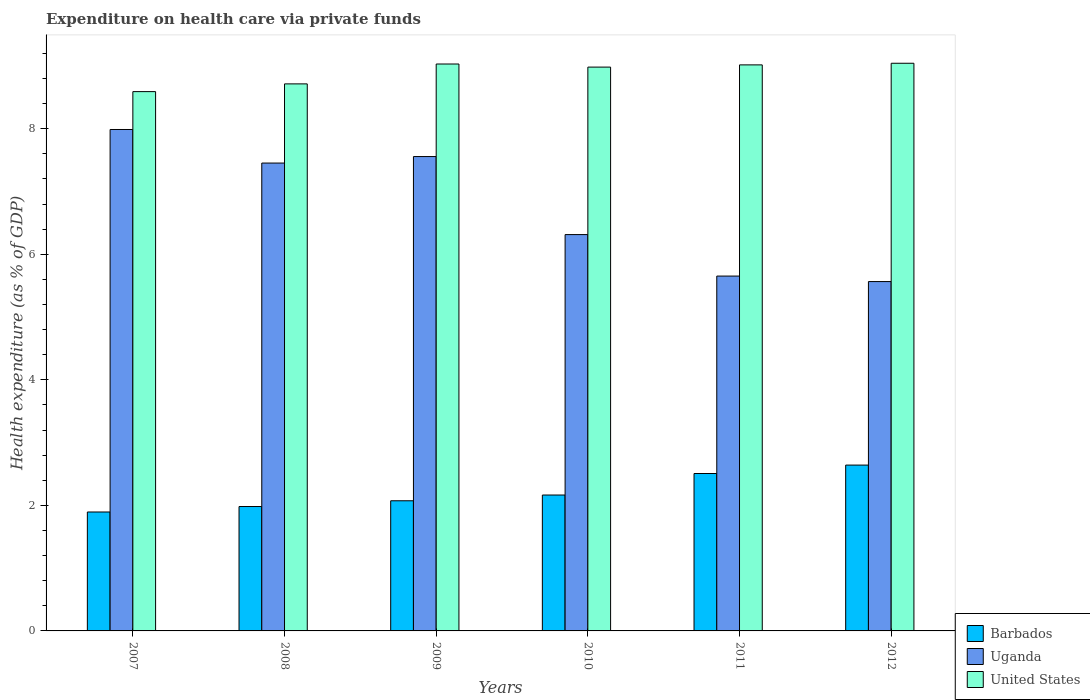How many groups of bars are there?
Ensure brevity in your answer.  6. Are the number of bars per tick equal to the number of legend labels?
Keep it short and to the point. Yes. Are the number of bars on each tick of the X-axis equal?
Provide a short and direct response. Yes. How many bars are there on the 4th tick from the left?
Offer a terse response. 3. How many bars are there on the 1st tick from the right?
Provide a short and direct response. 3. What is the label of the 1st group of bars from the left?
Your response must be concise. 2007. In how many cases, is the number of bars for a given year not equal to the number of legend labels?
Your answer should be very brief. 0. What is the expenditure made on health care in United States in 2007?
Offer a terse response. 8.59. Across all years, what is the maximum expenditure made on health care in United States?
Your answer should be compact. 9.04. Across all years, what is the minimum expenditure made on health care in Uganda?
Keep it short and to the point. 5.57. In which year was the expenditure made on health care in Uganda minimum?
Your answer should be very brief. 2012. What is the total expenditure made on health care in Uganda in the graph?
Offer a terse response. 40.53. What is the difference between the expenditure made on health care in Uganda in 2007 and that in 2009?
Offer a very short reply. 0.43. What is the difference between the expenditure made on health care in Uganda in 2010 and the expenditure made on health care in United States in 2012?
Provide a short and direct response. -2.73. What is the average expenditure made on health care in United States per year?
Provide a short and direct response. 8.9. In the year 2011, what is the difference between the expenditure made on health care in United States and expenditure made on health care in Barbados?
Offer a very short reply. 6.51. What is the ratio of the expenditure made on health care in United States in 2008 to that in 2012?
Offer a terse response. 0.96. Is the expenditure made on health care in Uganda in 2010 less than that in 2012?
Offer a terse response. No. Is the difference between the expenditure made on health care in United States in 2008 and 2011 greater than the difference between the expenditure made on health care in Barbados in 2008 and 2011?
Make the answer very short. Yes. What is the difference between the highest and the second highest expenditure made on health care in Uganda?
Offer a terse response. 0.43. What is the difference between the highest and the lowest expenditure made on health care in United States?
Your answer should be very brief. 0.45. In how many years, is the expenditure made on health care in United States greater than the average expenditure made on health care in United States taken over all years?
Provide a succinct answer. 4. What does the 1st bar from the left in 2012 represents?
Your answer should be compact. Barbados. What does the 3rd bar from the right in 2012 represents?
Your answer should be very brief. Barbados. How many bars are there?
Make the answer very short. 18. Are all the bars in the graph horizontal?
Provide a short and direct response. No. Are the values on the major ticks of Y-axis written in scientific E-notation?
Keep it short and to the point. No. Does the graph contain any zero values?
Offer a very short reply. No. Does the graph contain grids?
Keep it short and to the point. No. Where does the legend appear in the graph?
Give a very brief answer. Bottom right. What is the title of the graph?
Offer a very short reply. Expenditure on health care via private funds. What is the label or title of the X-axis?
Offer a very short reply. Years. What is the label or title of the Y-axis?
Offer a terse response. Health expenditure (as % of GDP). What is the Health expenditure (as % of GDP) in Barbados in 2007?
Ensure brevity in your answer.  1.89. What is the Health expenditure (as % of GDP) of Uganda in 2007?
Offer a terse response. 7.99. What is the Health expenditure (as % of GDP) of United States in 2007?
Provide a succinct answer. 8.59. What is the Health expenditure (as % of GDP) in Barbados in 2008?
Make the answer very short. 1.98. What is the Health expenditure (as % of GDP) in Uganda in 2008?
Make the answer very short. 7.45. What is the Health expenditure (as % of GDP) of United States in 2008?
Give a very brief answer. 8.71. What is the Health expenditure (as % of GDP) of Barbados in 2009?
Keep it short and to the point. 2.07. What is the Health expenditure (as % of GDP) of Uganda in 2009?
Your answer should be very brief. 7.56. What is the Health expenditure (as % of GDP) in United States in 2009?
Ensure brevity in your answer.  9.03. What is the Health expenditure (as % of GDP) in Barbados in 2010?
Ensure brevity in your answer.  2.16. What is the Health expenditure (as % of GDP) of Uganda in 2010?
Your answer should be compact. 6.31. What is the Health expenditure (as % of GDP) of United States in 2010?
Keep it short and to the point. 8.98. What is the Health expenditure (as % of GDP) of Barbados in 2011?
Offer a terse response. 2.51. What is the Health expenditure (as % of GDP) in Uganda in 2011?
Offer a terse response. 5.65. What is the Health expenditure (as % of GDP) in United States in 2011?
Make the answer very short. 9.02. What is the Health expenditure (as % of GDP) in Barbados in 2012?
Keep it short and to the point. 2.64. What is the Health expenditure (as % of GDP) in Uganda in 2012?
Your response must be concise. 5.57. What is the Health expenditure (as % of GDP) of United States in 2012?
Give a very brief answer. 9.04. Across all years, what is the maximum Health expenditure (as % of GDP) of Barbados?
Offer a terse response. 2.64. Across all years, what is the maximum Health expenditure (as % of GDP) of Uganda?
Offer a terse response. 7.99. Across all years, what is the maximum Health expenditure (as % of GDP) of United States?
Give a very brief answer. 9.04. Across all years, what is the minimum Health expenditure (as % of GDP) of Barbados?
Your response must be concise. 1.89. Across all years, what is the minimum Health expenditure (as % of GDP) in Uganda?
Give a very brief answer. 5.57. Across all years, what is the minimum Health expenditure (as % of GDP) of United States?
Provide a succinct answer. 8.59. What is the total Health expenditure (as % of GDP) in Barbados in the graph?
Keep it short and to the point. 13.26. What is the total Health expenditure (as % of GDP) of Uganda in the graph?
Provide a short and direct response. 40.53. What is the total Health expenditure (as % of GDP) of United States in the graph?
Your answer should be very brief. 53.38. What is the difference between the Health expenditure (as % of GDP) of Barbados in 2007 and that in 2008?
Your response must be concise. -0.09. What is the difference between the Health expenditure (as % of GDP) of Uganda in 2007 and that in 2008?
Give a very brief answer. 0.53. What is the difference between the Health expenditure (as % of GDP) of United States in 2007 and that in 2008?
Make the answer very short. -0.12. What is the difference between the Health expenditure (as % of GDP) in Barbados in 2007 and that in 2009?
Your answer should be compact. -0.18. What is the difference between the Health expenditure (as % of GDP) of Uganda in 2007 and that in 2009?
Your answer should be compact. 0.43. What is the difference between the Health expenditure (as % of GDP) in United States in 2007 and that in 2009?
Provide a short and direct response. -0.44. What is the difference between the Health expenditure (as % of GDP) of Barbados in 2007 and that in 2010?
Ensure brevity in your answer.  -0.27. What is the difference between the Health expenditure (as % of GDP) in Uganda in 2007 and that in 2010?
Your answer should be very brief. 1.67. What is the difference between the Health expenditure (as % of GDP) of United States in 2007 and that in 2010?
Your answer should be compact. -0.39. What is the difference between the Health expenditure (as % of GDP) of Barbados in 2007 and that in 2011?
Your answer should be compact. -0.61. What is the difference between the Health expenditure (as % of GDP) in Uganda in 2007 and that in 2011?
Your answer should be very brief. 2.33. What is the difference between the Health expenditure (as % of GDP) of United States in 2007 and that in 2011?
Your answer should be very brief. -0.43. What is the difference between the Health expenditure (as % of GDP) in Barbados in 2007 and that in 2012?
Provide a succinct answer. -0.75. What is the difference between the Health expenditure (as % of GDP) in Uganda in 2007 and that in 2012?
Your answer should be very brief. 2.42. What is the difference between the Health expenditure (as % of GDP) in United States in 2007 and that in 2012?
Provide a succinct answer. -0.45. What is the difference between the Health expenditure (as % of GDP) in Barbados in 2008 and that in 2009?
Offer a terse response. -0.09. What is the difference between the Health expenditure (as % of GDP) of Uganda in 2008 and that in 2009?
Your answer should be very brief. -0.1. What is the difference between the Health expenditure (as % of GDP) in United States in 2008 and that in 2009?
Your response must be concise. -0.32. What is the difference between the Health expenditure (as % of GDP) of Barbados in 2008 and that in 2010?
Offer a terse response. -0.18. What is the difference between the Health expenditure (as % of GDP) in Uganda in 2008 and that in 2010?
Make the answer very short. 1.14. What is the difference between the Health expenditure (as % of GDP) of United States in 2008 and that in 2010?
Offer a very short reply. -0.27. What is the difference between the Health expenditure (as % of GDP) in Barbados in 2008 and that in 2011?
Give a very brief answer. -0.53. What is the difference between the Health expenditure (as % of GDP) of Uganda in 2008 and that in 2011?
Make the answer very short. 1.8. What is the difference between the Health expenditure (as % of GDP) in United States in 2008 and that in 2011?
Your answer should be compact. -0.3. What is the difference between the Health expenditure (as % of GDP) in Barbados in 2008 and that in 2012?
Offer a terse response. -0.66. What is the difference between the Health expenditure (as % of GDP) of Uganda in 2008 and that in 2012?
Your answer should be compact. 1.89. What is the difference between the Health expenditure (as % of GDP) of United States in 2008 and that in 2012?
Give a very brief answer. -0.33. What is the difference between the Health expenditure (as % of GDP) in Barbados in 2009 and that in 2010?
Offer a very short reply. -0.09. What is the difference between the Health expenditure (as % of GDP) in Uganda in 2009 and that in 2010?
Your answer should be compact. 1.24. What is the difference between the Health expenditure (as % of GDP) of United States in 2009 and that in 2010?
Make the answer very short. 0.05. What is the difference between the Health expenditure (as % of GDP) in Barbados in 2009 and that in 2011?
Ensure brevity in your answer.  -0.43. What is the difference between the Health expenditure (as % of GDP) of Uganda in 2009 and that in 2011?
Give a very brief answer. 1.9. What is the difference between the Health expenditure (as % of GDP) in United States in 2009 and that in 2011?
Provide a short and direct response. 0.01. What is the difference between the Health expenditure (as % of GDP) of Barbados in 2009 and that in 2012?
Ensure brevity in your answer.  -0.57. What is the difference between the Health expenditure (as % of GDP) in Uganda in 2009 and that in 2012?
Keep it short and to the point. 1.99. What is the difference between the Health expenditure (as % of GDP) of United States in 2009 and that in 2012?
Give a very brief answer. -0.01. What is the difference between the Health expenditure (as % of GDP) of Barbados in 2010 and that in 2011?
Provide a short and direct response. -0.34. What is the difference between the Health expenditure (as % of GDP) of Uganda in 2010 and that in 2011?
Make the answer very short. 0.66. What is the difference between the Health expenditure (as % of GDP) in United States in 2010 and that in 2011?
Provide a succinct answer. -0.04. What is the difference between the Health expenditure (as % of GDP) of Barbados in 2010 and that in 2012?
Keep it short and to the point. -0.48. What is the difference between the Health expenditure (as % of GDP) of Uganda in 2010 and that in 2012?
Keep it short and to the point. 0.75. What is the difference between the Health expenditure (as % of GDP) of United States in 2010 and that in 2012?
Offer a very short reply. -0.06. What is the difference between the Health expenditure (as % of GDP) of Barbados in 2011 and that in 2012?
Your answer should be very brief. -0.13. What is the difference between the Health expenditure (as % of GDP) in Uganda in 2011 and that in 2012?
Give a very brief answer. 0.09. What is the difference between the Health expenditure (as % of GDP) of United States in 2011 and that in 2012?
Keep it short and to the point. -0.03. What is the difference between the Health expenditure (as % of GDP) of Barbados in 2007 and the Health expenditure (as % of GDP) of Uganda in 2008?
Offer a terse response. -5.56. What is the difference between the Health expenditure (as % of GDP) in Barbados in 2007 and the Health expenditure (as % of GDP) in United States in 2008?
Offer a terse response. -6.82. What is the difference between the Health expenditure (as % of GDP) in Uganda in 2007 and the Health expenditure (as % of GDP) in United States in 2008?
Offer a very short reply. -0.73. What is the difference between the Health expenditure (as % of GDP) in Barbados in 2007 and the Health expenditure (as % of GDP) in Uganda in 2009?
Make the answer very short. -5.66. What is the difference between the Health expenditure (as % of GDP) in Barbados in 2007 and the Health expenditure (as % of GDP) in United States in 2009?
Make the answer very short. -7.14. What is the difference between the Health expenditure (as % of GDP) in Uganda in 2007 and the Health expenditure (as % of GDP) in United States in 2009?
Provide a succinct answer. -1.04. What is the difference between the Health expenditure (as % of GDP) in Barbados in 2007 and the Health expenditure (as % of GDP) in Uganda in 2010?
Ensure brevity in your answer.  -4.42. What is the difference between the Health expenditure (as % of GDP) of Barbados in 2007 and the Health expenditure (as % of GDP) of United States in 2010?
Your answer should be very brief. -7.09. What is the difference between the Health expenditure (as % of GDP) of Uganda in 2007 and the Health expenditure (as % of GDP) of United States in 2010?
Provide a succinct answer. -0.99. What is the difference between the Health expenditure (as % of GDP) in Barbados in 2007 and the Health expenditure (as % of GDP) in Uganda in 2011?
Ensure brevity in your answer.  -3.76. What is the difference between the Health expenditure (as % of GDP) of Barbados in 2007 and the Health expenditure (as % of GDP) of United States in 2011?
Offer a very short reply. -7.12. What is the difference between the Health expenditure (as % of GDP) in Uganda in 2007 and the Health expenditure (as % of GDP) in United States in 2011?
Offer a terse response. -1.03. What is the difference between the Health expenditure (as % of GDP) of Barbados in 2007 and the Health expenditure (as % of GDP) of Uganda in 2012?
Offer a very short reply. -3.67. What is the difference between the Health expenditure (as % of GDP) in Barbados in 2007 and the Health expenditure (as % of GDP) in United States in 2012?
Offer a very short reply. -7.15. What is the difference between the Health expenditure (as % of GDP) in Uganda in 2007 and the Health expenditure (as % of GDP) in United States in 2012?
Provide a short and direct response. -1.05. What is the difference between the Health expenditure (as % of GDP) in Barbados in 2008 and the Health expenditure (as % of GDP) in Uganda in 2009?
Provide a short and direct response. -5.57. What is the difference between the Health expenditure (as % of GDP) of Barbados in 2008 and the Health expenditure (as % of GDP) of United States in 2009?
Make the answer very short. -7.05. What is the difference between the Health expenditure (as % of GDP) in Uganda in 2008 and the Health expenditure (as % of GDP) in United States in 2009?
Provide a succinct answer. -1.58. What is the difference between the Health expenditure (as % of GDP) of Barbados in 2008 and the Health expenditure (as % of GDP) of Uganda in 2010?
Your answer should be compact. -4.33. What is the difference between the Health expenditure (as % of GDP) of Barbados in 2008 and the Health expenditure (as % of GDP) of United States in 2010?
Provide a short and direct response. -7. What is the difference between the Health expenditure (as % of GDP) of Uganda in 2008 and the Health expenditure (as % of GDP) of United States in 2010?
Provide a succinct answer. -1.53. What is the difference between the Health expenditure (as % of GDP) in Barbados in 2008 and the Health expenditure (as % of GDP) in Uganda in 2011?
Your answer should be compact. -3.67. What is the difference between the Health expenditure (as % of GDP) in Barbados in 2008 and the Health expenditure (as % of GDP) in United States in 2011?
Offer a terse response. -7.04. What is the difference between the Health expenditure (as % of GDP) in Uganda in 2008 and the Health expenditure (as % of GDP) in United States in 2011?
Your answer should be compact. -1.56. What is the difference between the Health expenditure (as % of GDP) of Barbados in 2008 and the Health expenditure (as % of GDP) of Uganda in 2012?
Provide a succinct answer. -3.58. What is the difference between the Health expenditure (as % of GDP) in Barbados in 2008 and the Health expenditure (as % of GDP) in United States in 2012?
Your answer should be very brief. -7.06. What is the difference between the Health expenditure (as % of GDP) in Uganda in 2008 and the Health expenditure (as % of GDP) in United States in 2012?
Keep it short and to the point. -1.59. What is the difference between the Health expenditure (as % of GDP) in Barbados in 2009 and the Health expenditure (as % of GDP) in Uganda in 2010?
Your response must be concise. -4.24. What is the difference between the Health expenditure (as % of GDP) of Barbados in 2009 and the Health expenditure (as % of GDP) of United States in 2010?
Provide a succinct answer. -6.91. What is the difference between the Health expenditure (as % of GDP) of Uganda in 2009 and the Health expenditure (as % of GDP) of United States in 2010?
Give a very brief answer. -1.43. What is the difference between the Health expenditure (as % of GDP) in Barbados in 2009 and the Health expenditure (as % of GDP) in Uganda in 2011?
Provide a short and direct response. -3.58. What is the difference between the Health expenditure (as % of GDP) of Barbados in 2009 and the Health expenditure (as % of GDP) of United States in 2011?
Offer a terse response. -6.94. What is the difference between the Health expenditure (as % of GDP) in Uganda in 2009 and the Health expenditure (as % of GDP) in United States in 2011?
Your answer should be very brief. -1.46. What is the difference between the Health expenditure (as % of GDP) of Barbados in 2009 and the Health expenditure (as % of GDP) of Uganda in 2012?
Your answer should be compact. -3.49. What is the difference between the Health expenditure (as % of GDP) of Barbados in 2009 and the Health expenditure (as % of GDP) of United States in 2012?
Provide a succinct answer. -6.97. What is the difference between the Health expenditure (as % of GDP) in Uganda in 2009 and the Health expenditure (as % of GDP) in United States in 2012?
Make the answer very short. -1.49. What is the difference between the Health expenditure (as % of GDP) of Barbados in 2010 and the Health expenditure (as % of GDP) of Uganda in 2011?
Your response must be concise. -3.49. What is the difference between the Health expenditure (as % of GDP) in Barbados in 2010 and the Health expenditure (as % of GDP) in United States in 2011?
Offer a terse response. -6.85. What is the difference between the Health expenditure (as % of GDP) in Uganda in 2010 and the Health expenditure (as % of GDP) in United States in 2011?
Offer a terse response. -2.7. What is the difference between the Health expenditure (as % of GDP) in Barbados in 2010 and the Health expenditure (as % of GDP) in Uganda in 2012?
Ensure brevity in your answer.  -3.4. What is the difference between the Health expenditure (as % of GDP) of Barbados in 2010 and the Health expenditure (as % of GDP) of United States in 2012?
Offer a terse response. -6.88. What is the difference between the Health expenditure (as % of GDP) in Uganda in 2010 and the Health expenditure (as % of GDP) in United States in 2012?
Offer a terse response. -2.73. What is the difference between the Health expenditure (as % of GDP) in Barbados in 2011 and the Health expenditure (as % of GDP) in Uganda in 2012?
Give a very brief answer. -3.06. What is the difference between the Health expenditure (as % of GDP) in Barbados in 2011 and the Health expenditure (as % of GDP) in United States in 2012?
Ensure brevity in your answer.  -6.54. What is the difference between the Health expenditure (as % of GDP) of Uganda in 2011 and the Health expenditure (as % of GDP) of United States in 2012?
Your response must be concise. -3.39. What is the average Health expenditure (as % of GDP) of Barbados per year?
Ensure brevity in your answer.  2.21. What is the average Health expenditure (as % of GDP) in Uganda per year?
Give a very brief answer. 6.75. What is the average Health expenditure (as % of GDP) in United States per year?
Ensure brevity in your answer.  8.9. In the year 2007, what is the difference between the Health expenditure (as % of GDP) in Barbados and Health expenditure (as % of GDP) in Uganda?
Your response must be concise. -6.09. In the year 2007, what is the difference between the Health expenditure (as % of GDP) in Barbados and Health expenditure (as % of GDP) in United States?
Your answer should be very brief. -6.7. In the year 2007, what is the difference between the Health expenditure (as % of GDP) in Uganda and Health expenditure (as % of GDP) in United States?
Ensure brevity in your answer.  -0.6. In the year 2008, what is the difference between the Health expenditure (as % of GDP) of Barbados and Health expenditure (as % of GDP) of Uganda?
Make the answer very short. -5.47. In the year 2008, what is the difference between the Health expenditure (as % of GDP) in Barbados and Health expenditure (as % of GDP) in United States?
Ensure brevity in your answer.  -6.73. In the year 2008, what is the difference between the Health expenditure (as % of GDP) in Uganda and Health expenditure (as % of GDP) in United States?
Make the answer very short. -1.26. In the year 2009, what is the difference between the Health expenditure (as % of GDP) of Barbados and Health expenditure (as % of GDP) of Uganda?
Provide a short and direct response. -5.48. In the year 2009, what is the difference between the Health expenditure (as % of GDP) of Barbados and Health expenditure (as % of GDP) of United States?
Give a very brief answer. -6.96. In the year 2009, what is the difference between the Health expenditure (as % of GDP) of Uganda and Health expenditure (as % of GDP) of United States?
Keep it short and to the point. -1.47. In the year 2010, what is the difference between the Health expenditure (as % of GDP) of Barbados and Health expenditure (as % of GDP) of Uganda?
Keep it short and to the point. -4.15. In the year 2010, what is the difference between the Health expenditure (as % of GDP) of Barbados and Health expenditure (as % of GDP) of United States?
Your answer should be very brief. -6.82. In the year 2010, what is the difference between the Health expenditure (as % of GDP) of Uganda and Health expenditure (as % of GDP) of United States?
Provide a succinct answer. -2.67. In the year 2011, what is the difference between the Health expenditure (as % of GDP) of Barbados and Health expenditure (as % of GDP) of Uganda?
Provide a short and direct response. -3.15. In the year 2011, what is the difference between the Health expenditure (as % of GDP) in Barbados and Health expenditure (as % of GDP) in United States?
Make the answer very short. -6.51. In the year 2011, what is the difference between the Health expenditure (as % of GDP) in Uganda and Health expenditure (as % of GDP) in United States?
Offer a terse response. -3.36. In the year 2012, what is the difference between the Health expenditure (as % of GDP) in Barbados and Health expenditure (as % of GDP) in Uganda?
Your answer should be very brief. -2.92. In the year 2012, what is the difference between the Health expenditure (as % of GDP) of Barbados and Health expenditure (as % of GDP) of United States?
Offer a very short reply. -6.4. In the year 2012, what is the difference between the Health expenditure (as % of GDP) in Uganda and Health expenditure (as % of GDP) in United States?
Keep it short and to the point. -3.48. What is the ratio of the Health expenditure (as % of GDP) of Barbados in 2007 to that in 2008?
Make the answer very short. 0.96. What is the ratio of the Health expenditure (as % of GDP) of Uganda in 2007 to that in 2008?
Your response must be concise. 1.07. What is the ratio of the Health expenditure (as % of GDP) in United States in 2007 to that in 2008?
Your answer should be very brief. 0.99. What is the ratio of the Health expenditure (as % of GDP) of Barbados in 2007 to that in 2009?
Offer a very short reply. 0.91. What is the ratio of the Health expenditure (as % of GDP) in Uganda in 2007 to that in 2009?
Your answer should be compact. 1.06. What is the ratio of the Health expenditure (as % of GDP) of United States in 2007 to that in 2009?
Offer a terse response. 0.95. What is the ratio of the Health expenditure (as % of GDP) of Barbados in 2007 to that in 2010?
Your answer should be very brief. 0.88. What is the ratio of the Health expenditure (as % of GDP) in Uganda in 2007 to that in 2010?
Offer a terse response. 1.27. What is the ratio of the Health expenditure (as % of GDP) in United States in 2007 to that in 2010?
Keep it short and to the point. 0.96. What is the ratio of the Health expenditure (as % of GDP) in Barbados in 2007 to that in 2011?
Your answer should be compact. 0.76. What is the ratio of the Health expenditure (as % of GDP) in Uganda in 2007 to that in 2011?
Keep it short and to the point. 1.41. What is the ratio of the Health expenditure (as % of GDP) of United States in 2007 to that in 2011?
Your answer should be compact. 0.95. What is the ratio of the Health expenditure (as % of GDP) in Barbados in 2007 to that in 2012?
Ensure brevity in your answer.  0.72. What is the ratio of the Health expenditure (as % of GDP) of Uganda in 2007 to that in 2012?
Your answer should be compact. 1.44. What is the ratio of the Health expenditure (as % of GDP) of United States in 2007 to that in 2012?
Give a very brief answer. 0.95. What is the ratio of the Health expenditure (as % of GDP) of Barbados in 2008 to that in 2009?
Your answer should be compact. 0.96. What is the ratio of the Health expenditure (as % of GDP) in Uganda in 2008 to that in 2009?
Make the answer very short. 0.99. What is the ratio of the Health expenditure (as % of GDP) in United States in 2008 to that in 2009?
Provide a short and direct response. 0.96. What is the ratio of the Health expenditure (as % of GDP) of Barbados in 2008 to that in 2010?
Your response must be concise. 0.92. What is the ratio of the Health expenditure (as % of GDP) of Uganda in 2008 to that in 2010?
Make the answer very short. 1.18. What is the ratio of the Health expenditure (as % of GDP) in United States in 2008 to that in 2010?
Give a very brief answer. 0.97. What is the ratio of the Health expenditure (as % of GDP) of Barbados in 2008 to that in 2011?
Your answer should be compact. 0.79. What is the ratio of the Health expenditure (as % of GDP) in Uganda in 2008 to that in 2011?
Provide a succinct answer. 1.32. What is the ratio of the Health expenditure (as % of GDP) in United States in 2008 to that in 2011?
Provide a short and direct response. 0.97. What is the ratio of the Health expenditure (as % of GDP) of Barbados in 2008 to that in 2012?
Provide a short and direct response. 0.75. What is the ratio of the Health expenditure (as % of GDP) in Uganda in 2008 to that in 2012?
Provide a short and direct response. 1.34. What is the ratio of the Health expenditure (as % of GDP) of United States in 2008 to that in 2012?
Give a very brief answer. 0.96. What is the ratio of the Health expenditure (as % of GDP) in Barbados in 2009 to that in 2010?
Provide a short and direct response. 0.96. What is the ratio of the Health expenditure (as % of GDP) of Uganda in 2009 to that in 2010?
Provide a succinct answer. 1.2. What is the ratio of the Health expenditure (as % of GDP) of United States in 2009 to that in 2010?
Keep it short and to the point. 1.01. What is the ratio of the Health expenditure (as % of GDP) in Barbados in 2009 to that in 2011?
Ensure brevity in your answer.  0.83. What is the ratio of the Health expenditure (as % of GDP) in Uganda in 2009 to that in 2011?
Give a very brief answer. 1.34. What is the ratio of the Health expenditure (as % of GDP) of Barbados in 2009 to that in 2012?
Make the answer very short. 0.78. What is the ratio of the Health expenditure (as % of GDP) of Uganda in 2009 to that in 2012?
Provide a succinct answer. 1.36. What is the ratio of the Health expenditure (as % of GDP) of United States in 2009 to that in 2012?
Provide a short and direct response. 1. What is the ratio of the Health expenditure (as % of GDP) in Barbados in 2010 to that in 2011?
Provide a short and direct response. 0.86. What is the ratio of the Health expenditure (as % of GDP) in Uganda in 2010 to that in 2011?
Give a very brief answer. 1.12. What is the ratio of the Health expenditure (as % of GDP) in Barbados in 2010 to that in 2012?
Your response must be concise. 0.82. What is the ratio of the Health expenditure (as % of GDP) in Uganda in 2010 to that in 2012?
Ensure brevity in your answer.  1.13. What is the ratio of the Health expenditure (as % of GDP) of United States in 2010 to that in 2012?
Make the answer very short. 0.99. What is the ratio of the Health expenditure (as % of GDP) in Barbados in 2011 to that in 2012?
Keep it short and to the point. 0.95. What is the ratio of the Health expenditure (as % of GDP) of Uganda in 2011 to that in 2012?
Offer a very short reply. 1.02. What is the difference between the highest and the second highest Health expenditure (as % of GDP) in Barbados?
Make the answer very short. 0.13. What is the difference between the highest and the second highest Health expenditure (as % of GDP) in Uganda?
Your answer should be compact. 0.43. What is the difference between the highest and the second highest Health expenditure (as % of GDP) of United States?
Your answer should be compact. 0.01. What is the difference between the highest and the lowest Health expenditure (as % of GDP) of Barbados?
Offer a very short reply. 0.75. What is the difference between the highest and the lowest Health expenditure (as % of GDP) of Uganda?
Your answer should be compact. 2.42. What is the difference between the highest and the lowest Health expenditure (as % of GDP) of United States?
Give a very brief answer. 0.45. 